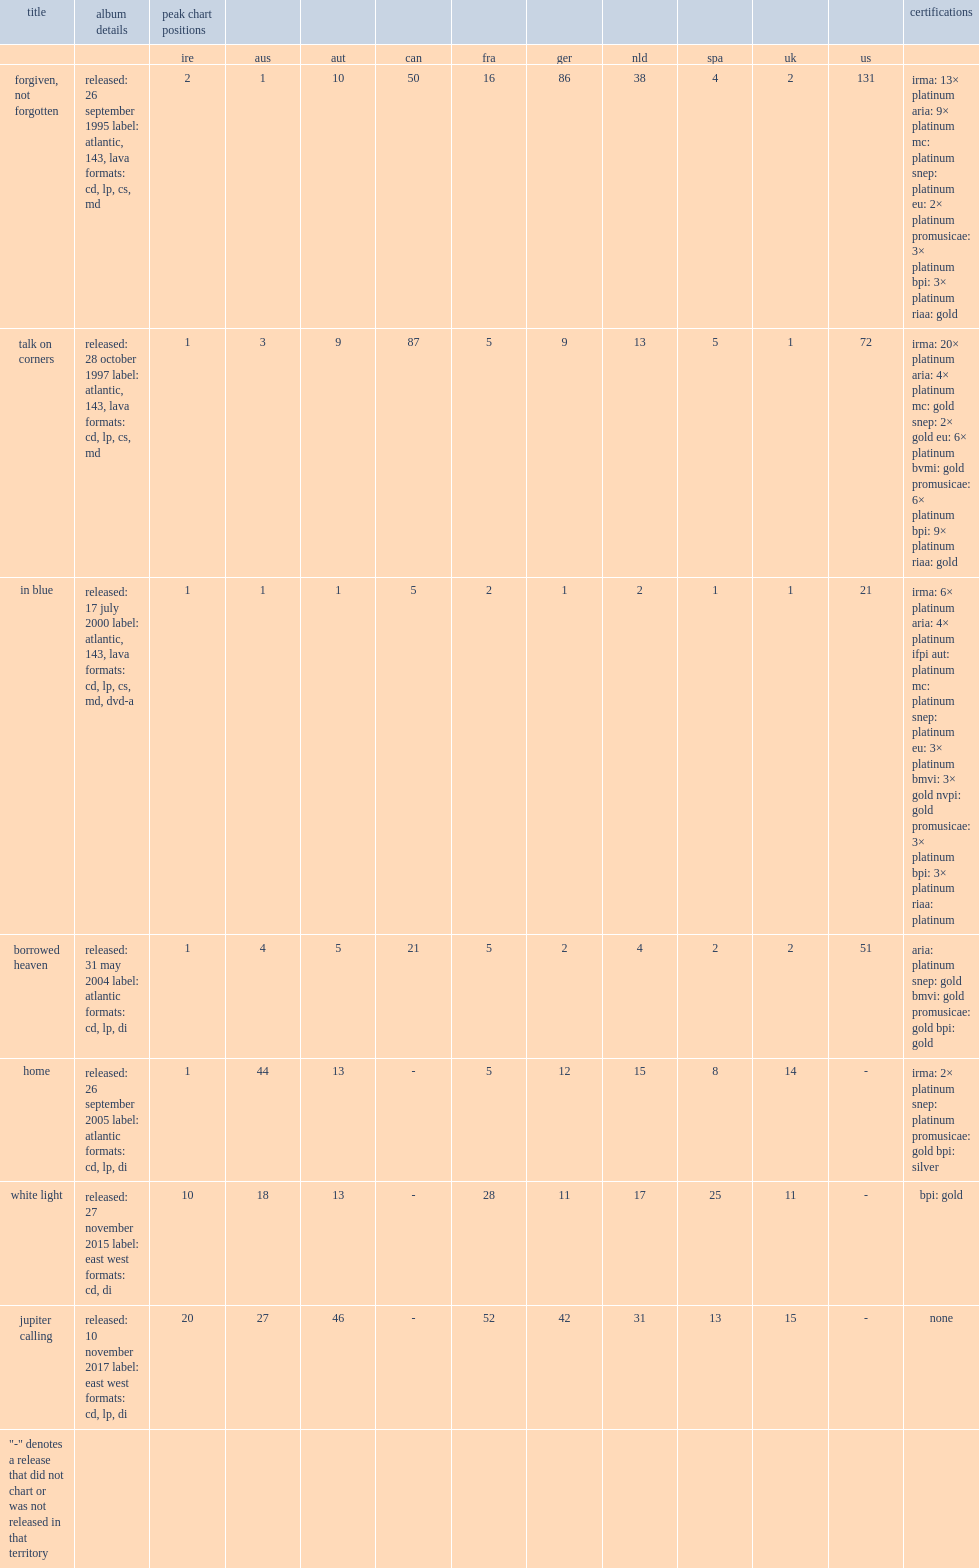When did the album forgiven, not forgotten release? Released: 26 september 1995 label: atlantic, 143, lava formats: cd, lp, cs, md. 